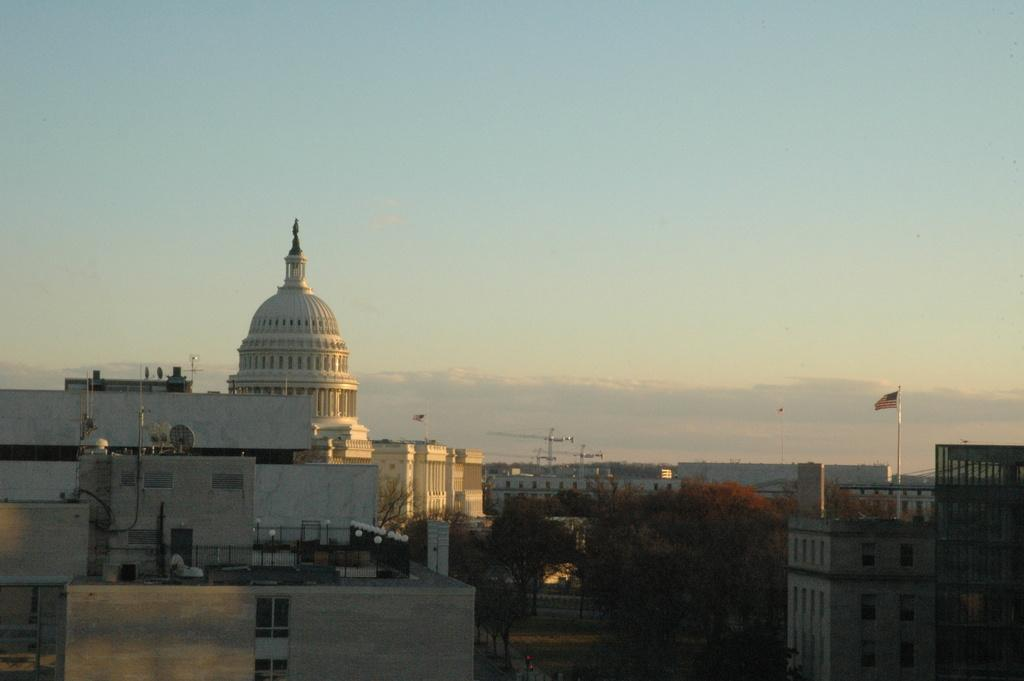What type of structures can be seen in the image? There are buildings in the image. What other natural elements are present in the image? There are trees in the image. Are there any symbols or markers visible in the image? Yes, there are flags in the image. What can be seen in the sky in the image? The sky is visible in the image. What is at the bottom of the image? There is a road at the bottom of the image. Can you see any yams growing on the side of the road in the image? There are no yams visible in the image; it features buildings, trees, flags, the sky, and a road. Is there a slip visible on the road in the image? There is no slip present on the road in the image. 